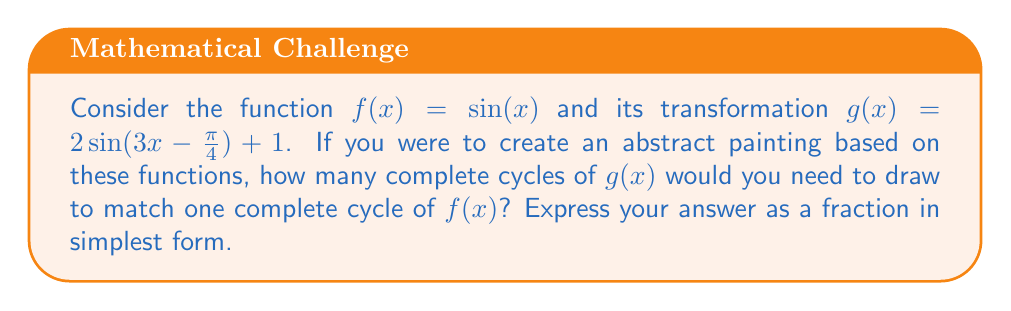Could you help me with this problem? Let's approach this step-by-step:

1) First, recall that one complete cycle of $\sin(x)$ occurs over an interval of $2\pi$.

2) Now, let's analyze the transformation $g(x) = 2\sin(3x-\frac{\pi}{4}) + 1$:
   - The $+1$ at the end is a vertical shift and doesn't affect the cycle length.
   - The 2 in front is a vertical stretch and also doesn't affect the cycle length.
   - The key transformation affecting the cycle length is inside the sine function: $3x-\frac{\pi}{4}$

3) The $-\frac{\pi}{4}$ is a phase shift and doesn't change the cycle length. The important factor is the $3x$.

4) When we have $\sin(3x)$, it means the function completes a full cycle three times as fast as $\sin(x)$.

5) So, while $f(x) = \sin(x)$ completes one cycle over $2\pi$, $g(x)$ will complete one cycle over $\frac{2\pi}{3}$.

6) To find how many cycles of $g(x)$ fit in one cycle of $f(x)$, we divide:

   $\frac{2\pi}{\frac{2\pi}{3}} = 2\pi \cdot \frac{3}{2\pi} = 3$

Therefore, 3 complete cycles of $g(x)$ will fit in one complete cycle of $f(x)$.
Answer: $3$ 